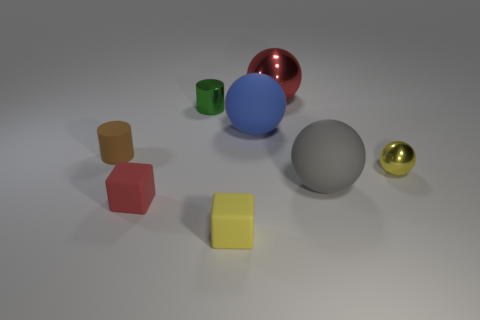Is the shape of the small shiny thing in front of the green shiny cylinder the same as  the small yellow rubber thing?
Provide a succinct answer. No. The tiny ball that is made of the same material as the large red ball is what color?
Ensure brevity in your answer.  Yellow. What is the material of the red object that is in front of the yellow metal thing?
Offer a terse response. Rubber. Does the large red metal thing have the same shape as the rubber object that is to the left of the red rubber cube?
Ensure brevity in your answer.  No. There is a thing that is right of the small green cylinder and left of the blue rubber thing; what is its material?
Give a very brief answer. Rubber. The shiny sphere that is the same size as the brown matte thing is what color?
Give a very brief answer. Yellow. Is the tiny brown cylinder made of the same material as the sphere that is behind the green cylinder?
Make the answer very short. No. How many other objects are the same size as the green shiny object?
Provide a short and direct response. 4. There is a large ball to the right of the metal ball that is behind the tiny yellow shiny ball; is there a tiny matte cylinder that is behind it?
Your answer should be compact. Yes. What size is the blue object?
Give a very brief answer. Large. 